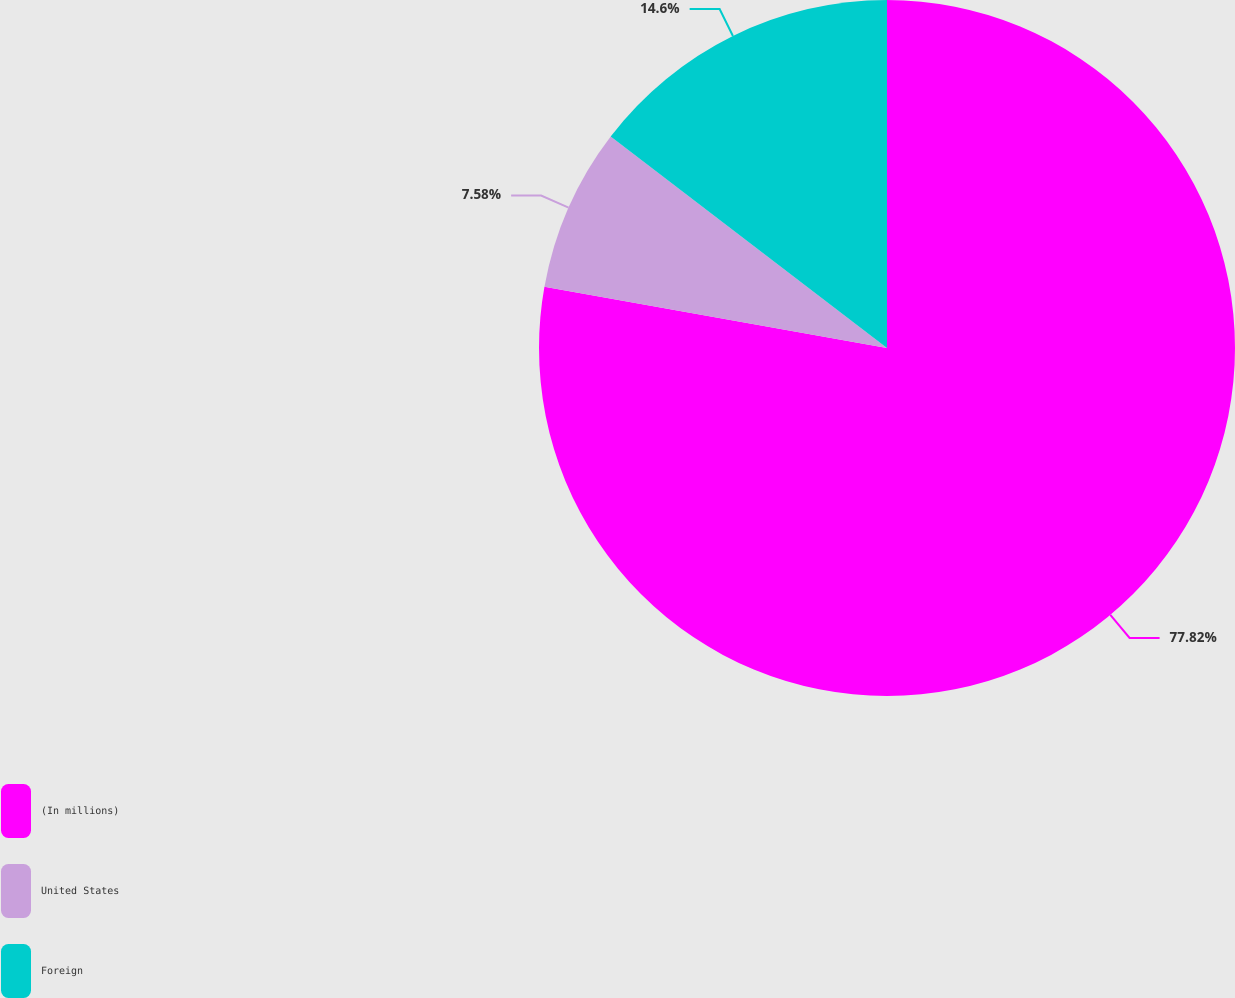Convert chart. <chart><loc_0><loc_0><loc_500><loc_500><pie_chart><fcel>(In millions)<fcel>United States<fcel>Foreign<nl><fcel>77.82%<fcel>7.58%<fcel>14.6%<nl></chart> 